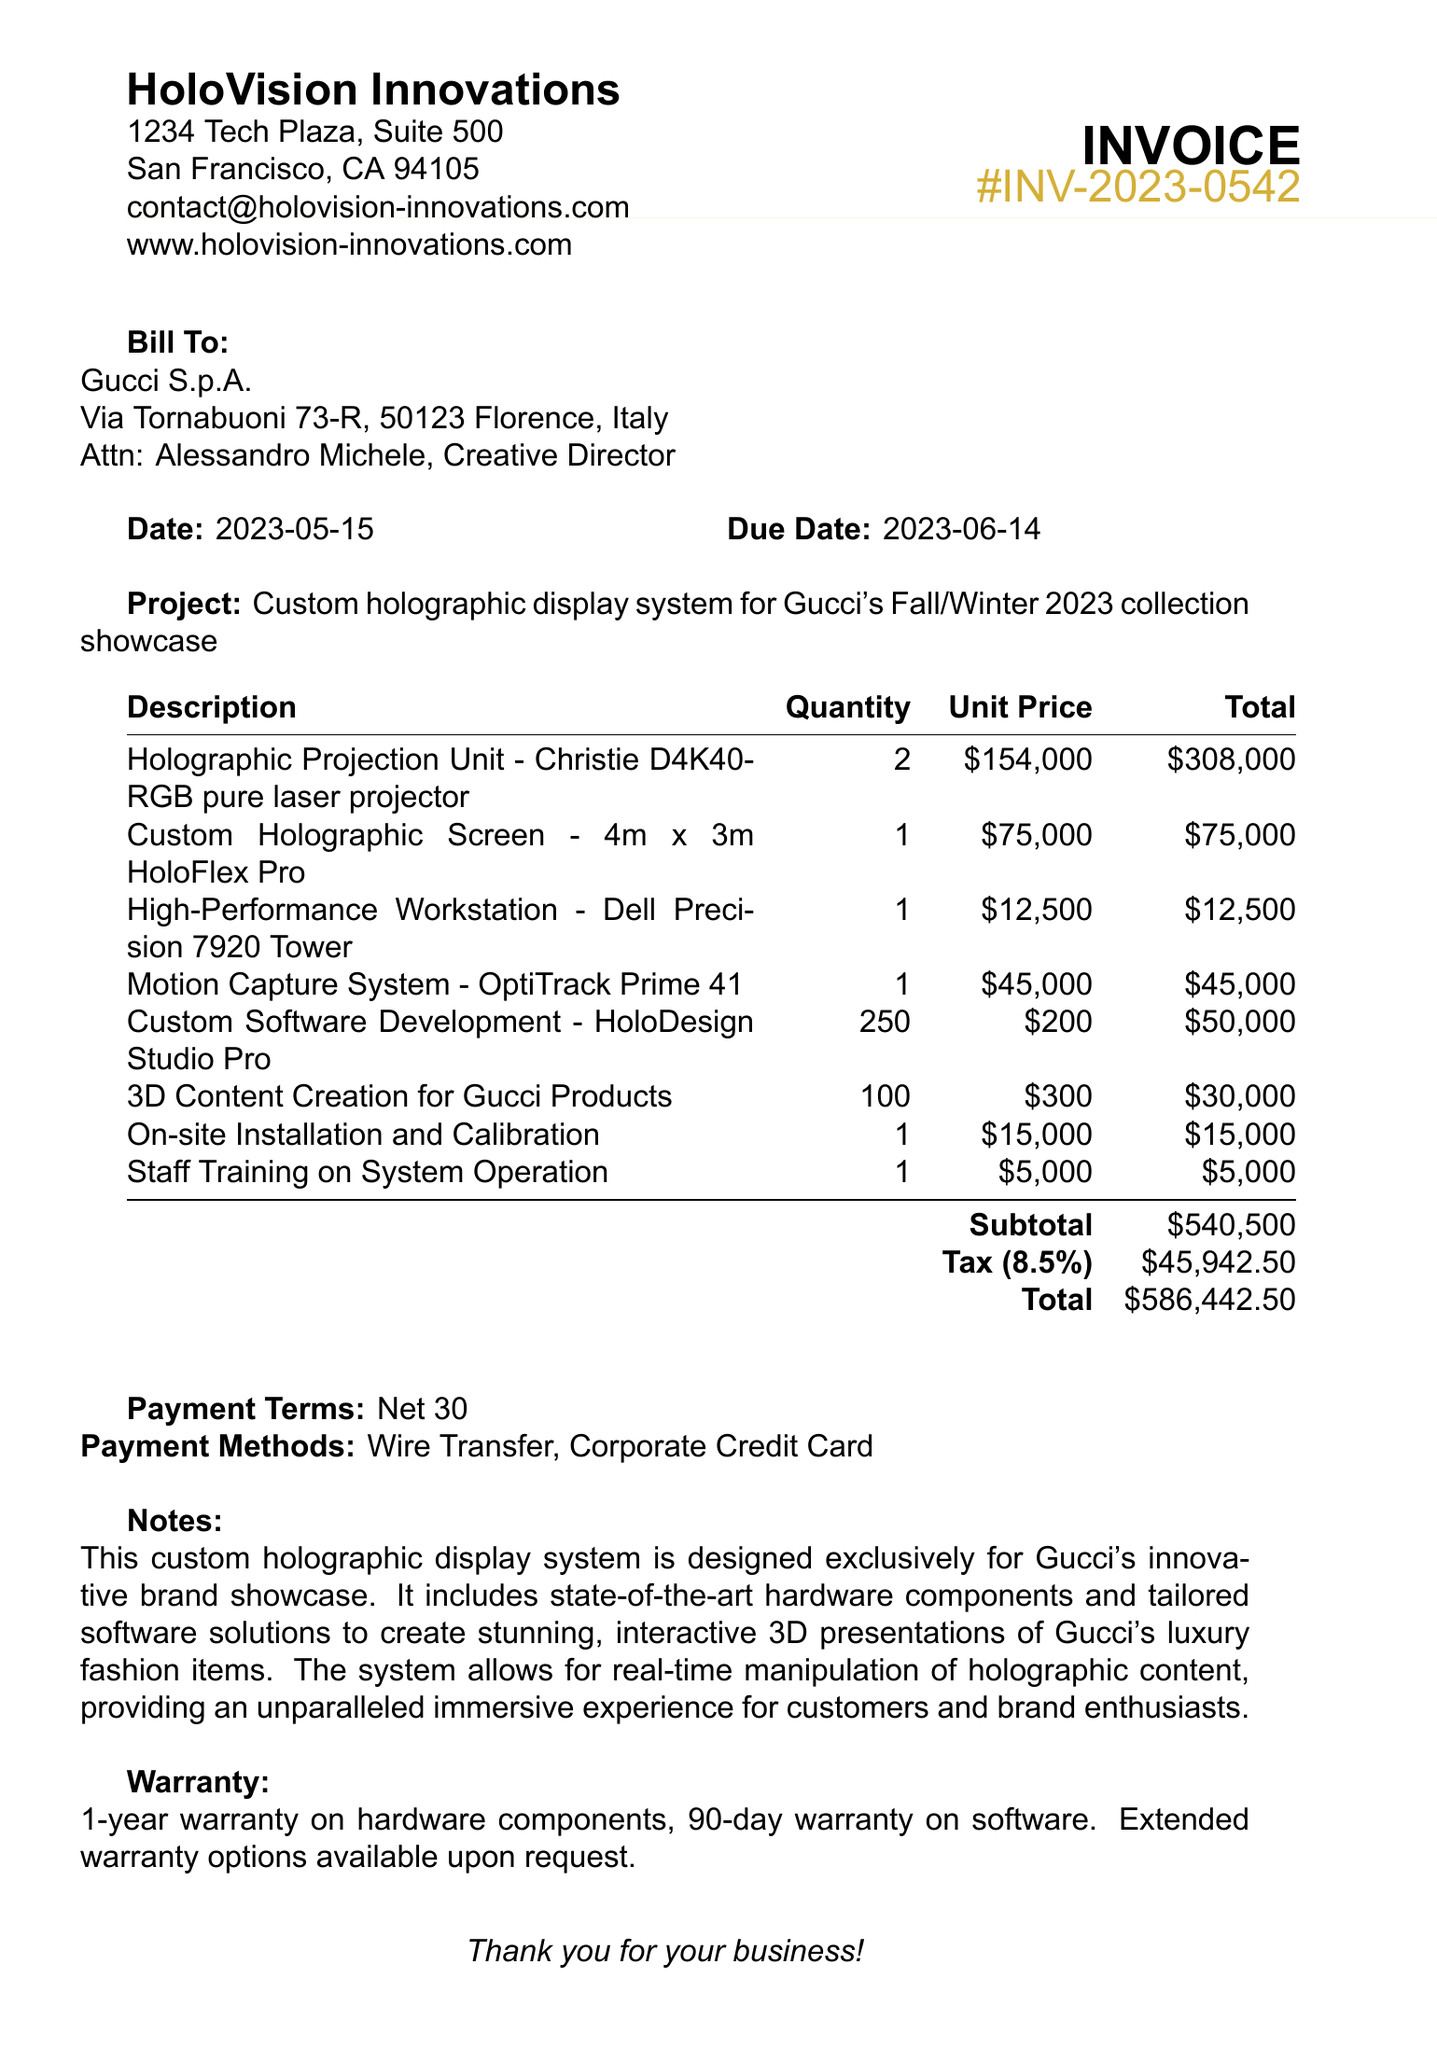What is the invoice number? The invoice number is listed in the document as a unique identifier for the invoice.
Answer: INV-2023-0542 Who is the contact person at Gucci? The contact person is mentioned in the document under the client information section.
Answer: Alessandro Michele, Creative Director What is the total amount due? The total amount due is calculated from the subtotal and tax provided in the document.
Answer: 586442.50 When is the due date for the invoice? The due date is stated in the document, indicating when payment is required.
Answer: 2023-06-14 How many holographic projection units are included in the invoice? The quantity of holographic projection units is listed in the line items of the invoice.
Answer: 2 What is the subtotal before tax? The subtotal amount is shown separately in the document, detailing the cost before any taxes are applied.
Answer: 540500 What hardware warranty period is provided? The warranty period for hardware components is specifically mentioned in the warranty section of the document.
Answer: 1-year What is the project description? The project description summarizes the purpose and nature of the services provided as stated in the document.
Answer: Custom holographic display system for Gucci's Fall/Winter 2023 collection showcase What payment methods are accepted? The payment methods are listed as options available for payment in the document.
Answer: Wire Transfer, Corporate Credit Card 